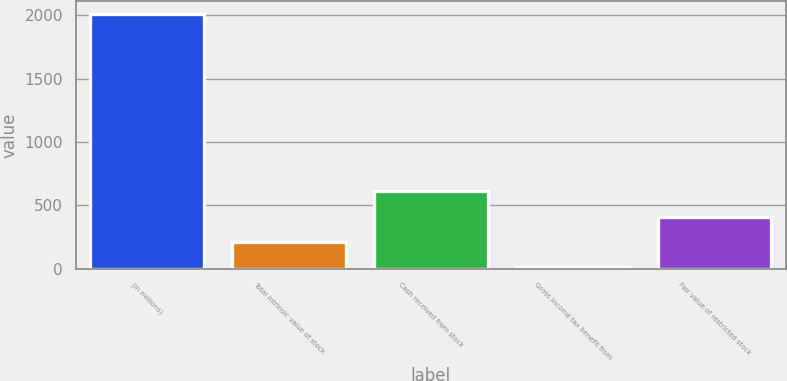Convert chart. <chart><loc_0><loc_0><loc_500><loc_500><bar_chart><fcel>(In millions)<fcel>Total intrinsic value of stock<fcel>Cash received from stock<fcel>Gross income tax benefit from<fcel>Fair value of restricted stock<nl><fcel>2013<fcel>210.3<fcel>610.9<fcel>10<fcel>410.6<nl></chart> 